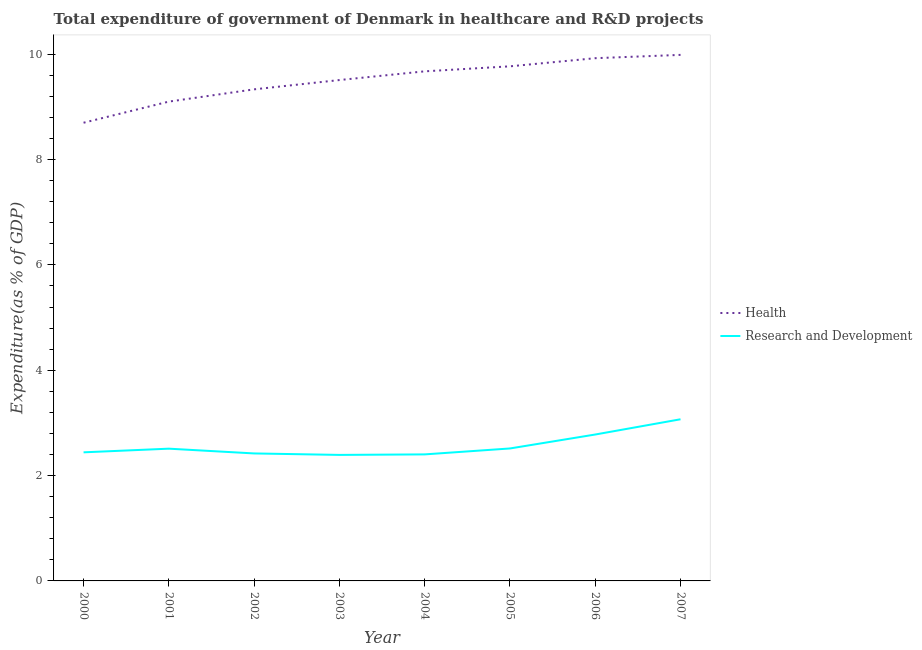Does the line corresponding to expenditure in r&d intersect with the line corresponding to expenditure in healthcare?
Keep it short and to the point. No. What is the expenditure in healthcare in 2003?
Give a very brief answer. 9.51. Across all years, what is the maximum expenditure in r&d?
Give a very brief answer. 3.07. Across all years, what is the minimum expenditure in healthcare?
Offer a very short reply. 8.7. In which year was the expenditure in healthcare maximum?
Make the answer very short. 2007. In which year was the expenditure in healthcare minimum?
Give a very brief answer. 2000. What is the total expenditure in r&d in the graph?
Your response must be concise. 20.53. What is the difference between the expenditure in healthcare in 2003 and that in 2006?
Give a very brief answer. -0.41. What is the difference between the expenditure in healthcare in 2007 and the expenditure in r&d in 2002?
Offer a terse response. 7.57. What is the average expenditure in r&d per year?
Keep it short and to the point. 2.57. In the year 2000, what is the difference between the expenditure in r&d and expenditure in healthcare?
Your answer should be very brief. -6.26. In how many years, is the expenditure in healthcare greater than 2.8 %?
Provide a short and direct response. 8. What is the ratio of the expenditure in healthcare in 2004 to that in 2007?
Provide a succinct answer. 0.97. Is the expenditure in healthcare in 2003 less than that in 2007?
Your answer should be very brief. Yes. What is the difference between the highest and the second highest expenditure in healthcare?
Make the answer very short. 0.06. What is the difference between the highest and the lowest expenditure in healthcare?
Your response must be concise. 1.29. Is the sum of the expenditure in r&d in 2005 and 2006 greater than the maximum expenditure in healthcare across all years?
Keep it short and to the point. No. Does the expenditure in r&d monotonically increase over the years?
Offer a very short reply. No. Is the expenditure in healthcare strictly greater than the expenditure in r&d over the years?
Your response must be concise. Yes. How many lines are there?
Offer a very short reply. 2. How many years are there in the graph?
Offer a very short reply. 8. Are the values on the major ticks of Y-axis written in scientific E-notation?
Ensure brevity in your answer.  No. How many legend labels are there?
Keep it short and to the point. 2. How are the legend labels stacked?
Your response must be concise. Vertical. What is the title of the graph?
Your response must be concise. Total expenditure of government of Denmark in healthcare and R&D projects. What is the label or title of the Y-axis?
Keep it short and to the point. Expenditure(as % of GDP). What is the Expenditure(as % of GDP) of Health in 2000?
Keep it short and to the point. 8.7. What is the Expenditure(as % of GDP) in Research and Development in 2000?
Provide a short and direct response. 2.44. What is the Expenditure(as % of GDP) of Health in 2001?
Ensure brevity in your answer.  9.1. What is the Expenditure(as % of GDP) of Research and Development in 2001?
Give a very brief answer. 2.51. What is the Expenditure(as % of GDP) in Health in 2002?
Give a very brief answer. 9.33. What is the Expenditure(as % of GDP) in Research and Development in 2002?
Keep it short and to the point. 2.42. What is the Expenditure(as % of GDP) in Health in 2003?
Offer a terse response. 9.51. What is the Expenditure(as % of GDP) of Research and Development in 2003?
Your answer should be compact. 2.39. What is the Expenditure(as % of GDP) in Health in 2004?
Make the answer very short. 9.67. What is the Expenditure(as % of GDP) in Research and Development in 2004?
Your response must be concise. 2.4. What is the Expenditure(as % of GDP) of Health in 2005?
Your answer should be very brief. 9.77. What is the Expenditure(as % of GDP) in Research and Development in 2005?
Your answer should be very brief. 2.51. What is the Expenditure(as % of GDP) of Health in 2006?
Offer a very short reply. 9.92. What is the Expenditure(as % of GDP) of Research and Development in 2006?
Provide a succinct answer. 2.78. What is the Expenditure(as % of GDP) of Health in 2007?
Ensure brevity in your answer.  9.99. What is the Expenditure(as % of GDP) of Research and Development in 2007?
Ensure brevity in your answer.  3.07. Across all years, what is the maximum Expenditure(as % of GDP) of Health?
Your answer should be compact. 9.99. Across all years, what is the maximum Expenditure(as % of GDP) of Research and Development?
Provide a succinct answer. 3.07. Across all years, what is the minimum Expenditure(as % of GDP) of Health?
Provide a succinct answer. 8.7. Across all years, what is the minimum Expenditure(as % of GDP) in Research and Development?
Your response must be concise. 2.39. What is the total Expenditure(as % of GDP) of Health in the graph?
Offer a terse response. 76. What is the total Expenditure(as % of GDP) of Research and Development in the graph?
Offer a terse response. 20.53. What is the difference between the Expenditure(as % of GDP) in Health in 2000 and that in 2001?
Offer a terse response. -0.4. What is the difference between the Expenditure(as % of GDP) in Research and Development in 2000 and that in 2001?
Provide a short and direct response. -0.07. What is the difference between the Expenditure(as % of GDP) in Health in 2000 and that in 2002?
Ensure brevity in your answer.  -0.63. What is the difference between the Expenditure(as % of GDP) of Research and Development in 2000 and that in 2002?
Make the answer very short. 0.02. What is the difference between the Expenditure(as % of GDP) in Health in 2000 and that in 2003?
Keep it short and to the point. -0.81. What is the difference between the Expenditure(as % of GDP) of Research and Development in 2000 and that in 2003?
Make the answer very short. 0.05. What is the difference between the Expenditure(as % of GDP) in Health in 2000 and that in 2004?
Give a very brief answer. -0.98. What is the difference between the Expenditure(as % of GDP) of Research and Development in 2000 and that in 2004?
Provide a succinct answer. 0.04. What is the difference between the Expenditure(as % of GDP) in Health in 2000 and that in 2005?
Your answer should be very brief. -1.07. What is the difference between the Expenditure(as % of GDP) in Research and Development in 2000 and that in 2005?
Your answer should be very brief. -0.07. What is the difference between the Expenditure(as % of GDP) of Health in 2000 and that in 2006?
Offer a very short reply. -1.23. What is the difference between the Expenditure(as % of GDP) of Research and Development in 2000 and that in 2006?
Ensure brevity in your answer.  -0.34. What is the difference between the Expenditure(as % of GDP) of Health in 2000 and that in 2007?
Provide a short and direct response. -1.29. What is the difference between the Expenditure(as % of GDP) of Research and Development in 2000 and that in 2007?
Offer a very short reply. -0.63. What is the difference between the Expenditure(as % of GDP) in Health in 2001 and that in 2002?
Provide a short and direct response. -0.23. What is the difference between the Expenditure(as % of GDP) of Research and Development in 2001 and that in 2002?
Offer a terse response. 0.09. What is the difference between the Expenditure(as % of GDP) in Health in 2001 and that in 2003?
Offer a very short reply. -0.41. What is the difference between the Expenditure(as % of GDP) in Research and Development in 2001 and that in 2003?
Offer a very short reply. 0.12. What is the difference between the Expenditure(as % of GDP) of Health in 2001 and that in 2004?
Offer a terse response. -0.57. What is the difference between the Expenditure(as % of GDP) of Research and Development in 2001 and that in 2004?
Provide a short and direct response. 0.11. What is the difference between the Expenditure(as % of GDP) of Health in 2001 and that in 2005?
Keep it short and to the point. -0.67. What is the difference between the Expenditure(as % of GDP) of Research and Development in 2001 and that in 2005?
Provide a succinct answer. -0. What is the difference between the Expenditure(as % of GDP) of Health in 2001 and that in 2006?
Give a very brief answer. -0.82. What is the difference between the Expenditure(as % of GDP) of Research and Development in 2001 and that in 2006?
Your response must be concise. -0.27. What is the difference between the Expenditure(as % of GDP) of Health in 2001 and that in 2007?
Provide a succinct answer. -0.89. What is the difference between the Expenditure(as % of GDP) in Research and Development in 2001 and that in 2007?
Offer a terse response. -0.56. What is the difference between the Expenditure(as % of GDP) in Health in 2002 and that in 2003?
Your answer should be very brief. -0.18. What is the difference between the Expenditure(as % of GDP) in Research and Development in 2002 and that in 2003?
Your response must be concise. 0.03. What is the difference between the Expenditure(as % of GDP) of Health in 2002 and that in 2004?
Provide a short and direct response. -0.34. What is the difference between the Expenditure(as % of GDP) in Research and Development in 2002 and that in 2004?
Your answer should be compact. 0.02. What is the difference between the Expenditure(as % of GDP) of Health in 2002 and that in 2005?
Ensure brevity in your answer.  -0.44. What is the difference between the Expenditure(as % of GDP) in Research and Development in 2002 and that in 2005?
Your answer should be compact. -0.09. What is the difference between the Expenditure(as % of GDP) in Health in 2002 and that in 2006?
Give a very brief answer. -0.59. What is the difference between the Expenditure(as % of GDP) in Research and Development in 2002 and that in 2006?
Offer a very short reply. -0.36. What is the difference between the Expenditure(as % of GDP) in Health in 2002 and that in 2007?
Your answer should be compact. -0.65. What is the difference between the Expenditure(as % of GDP) of Research and Development in 2002 and that in 2007?
Give a very brief answer. -0.65. What is the difference between the Expenditure(as % of GDP) of Health in 2003 and that in 2004?
Keep it short and to the point. -0.17. What is the difference between the Expenditure(as % of GDP) in Research and Development in 2003 and that in 2004?
Provide a succinct answer. -0.01. What is the difference between the Expenditure(as % of GDP) of Health in 2003 and that in 2005?
Give a very brief answer. -0.26. What is the difference between the Expenditure(as % of GDP) of Research and Development in 2003 and that in 2005?
Your answer should be very brief. -0.12. What is the difference between the Expenditure(as % of GDP) of Health in 2003 and that in 2006?
Provide a succinct answer. -0.41. What is the difference between the Expenditure(as % of GDP) in Research and Development in 2003 and that in 2006?
Offer a terse response. -0.39. What is the difference between the Expenditure(as % of GDP) in Health in 2003 and that in 2007?
Offer a terse response. -0.48. What is the difference between the Expenditure(as % of GDP) in Research and Development in 2003 and that in 2007?
Make the answer very short. -0.68. What is the difference between the Expenditure(as % of GDP) of Health in 2004 and that in 2005?
Offer a very short reply. -0.1. What is the difference between the Expenditure(as % of GDP) of Research and Development in 2004 and that in 2005?
Your answer should be compact. -0.11. What is the difference between the Expenditure(as % of GDP) in Health in 2004 and that in 2006?
Offer a very short reply. -0.25. What is the difference between the Expenditure(as % of GDP) of Research and Development in 2004 and that in 2006?
Your answer should be very brief. -0.38. What is the difference between the Expenditure(as % of GDP) of Health in 2004 and that in 2007?
Offer a very short reply. -0.31. What is the difference between the Expenditure(as % of GDP) of Research and Development in 2004 and that in 2007?
Keep it short and to the point. -0.67. What is the difference between the Expenditure(as % of GDP) of Health in 2005 and that in 2006?
Your answer should be compact. -0.15. What is the difference between the Expenditure(as % of GDP) of Research and Development in 2005 and that in 2006?
Keep it short and to the point. -0.26. What is the difference between the Expenditure(as % of GDP) of Health in 2005 and that in 2007?
Keep it short and to the point. -0.22. What is the difference between the Expenditure(as % of GDP) of Research and Development in 2005 and that in 2007?
Give a very brief answer. -0.55. What is the difference between the Expenditure(as % of GDP) of Health in 2006 and that in 2007?
Your answer should be very brief. -0.06. What is the difference between the Expenditure(as % of GDP) of Research and Development in 2006 and that in 2007?
Provide a succinct answer. -0.29. What is the difference between the Expenditure(as % of GDP) of Health in 2000 and the Expenditure(as % of GDP) of Research and Development in 2001?
Your answer should be very brief. 6.19. What is the difference between the Expenditure(as % of GDP) in Health in 2000 and the Expenditure(as % of GDP) in Research and Development in 2002?
Your answer should be very brief. 6.28. What is the difference between the Expenditure(as % of GDP) in Health in 2000 and the Expenditure(as % of GDP) in Research and Development in 2003?
Keep it short and to the point. 6.31. What is the difference between the Expenditure(as % of GDP) of Health in 2000 and the Expenditure(as % of GDP) of Research and Development in 2004?
Ensure brevity in your answer.  6.3. What is the difference between the Expenditure(as % of GDP) in Health in 2000 and the Expenditure(as % of GDP) in Research and Development in 2005?
Your answer should be compact. 6.18. What is the difference between the Expenditure(as % of GDP) in Health in 2000 and the Expenditure(as % of GDP) in Research and Development in 2006?
Your answer should be compact. 5.92. What is the difference between the Expenditure(as % of GDP) of Health in 2000 and the Expenditure(as % of GDP) of Research and Development in 2007?
Offer a very short reply. 5.63. What is the difference between the Expenditure(as % of GDP) in Health in 2001 and the Expenditure(as % of GDP) in Research and Development in 2002?
Provide a short and direct response. 6.68. What is the difference between the Expenditure(as % of GDP) of Health in 2001 and the Expenditure(as % of GDP) of Research and Development in 2003?
Your response must be concise. 6.71. What is the difference between the Expenditure(as % of GDP) in Health in 2001 and the Expenditure(as % of GDP) in Research and Development in 2004?
Your answer should be compact. 6.7. What is the difference between the Expenditure(as % of GDP) in Health in 2001 and the Expenditure(as % of GDP) in Research and Development in 2005?
Keep it short and to the point. 6.59. What is the difference between the Expenditure(as % of GDP) in Health in 2001 and the Expenditure(as % of GDP) in Research and Development in 2006?
Keep it short and to the point. 6.32. What is the difference between the Expenditure(as % of GDP) of Health in 2001 and the Expenditure(as % of GDP) of Research and Development in 2007?
Give a very brief answer. 6.03. What is the difference between the Expenditure(as % of GDP) of Health in 2002 and the Expenditure(as % of GDP) of Research and Development in 2003?
Your answer should be very brief. 6.94. What is the difference between the Expenditure(as % of GDP) in Health in 2002 and the Expenditure(as % of GDP) in Research and Development in 2004?
Keep it short and to the point. 6.93. What is the difference between the Expenditure(as % of GDP) of Health in 2002 and the Expenditure(as % of GDP) of Research and Development in 2005?
Keep it short and to the point. 6.82. What is the difference between the Expenditure(as % of GDP) of Health in 2002 and the Expenditure(as % of GDP) of Research and Development in 2006?
Make the answer very short. 6.55. What is the difference between the Expenditure(as % of GDP) in Health in 2002 and the Expenditure(as % of GDP) in Research and Development in 2007?
Provide a short and direct response. 6.26. What is the difference between the Expenditure(as % of GDP) of Health in 2003 and the Expenditure(as % of GDP) of Research and Development in 2004?
Keep it short and to the point. 7.11. What is the difference between the Expenditure(as % of GDP) of Health in 2003 and the Expenditure(as % of GDP) of Research and Development in 2005?
Offer a very short reply. 6.99. What is the difference between the Expenditure(as % of GDP) of Health in 2003 and the Expenditure(as % of GDP) of Research and Development in 2006?
Your answer should be compact. 6.73. What is the difference between the Expenditure(as % of GDP) in Health in 2003 and the Expenditure(as % of GDP) in Research and Development in 2007?
Offer a very short reply. 6.44. What is the difference between the Expenditure(as % of GDP) of Health in 2004 and the Expenditure(as % of GDP) of Research and Development in 2005?
Offer a terse response. 7.16. What is the difference between the Expenditure(as % of GDP) in Health in 2004 and the Expenditure(as % of GDP) in Research and Development in 2006?
Provide a short and direct response. 6.9. What is the difference between the Expenditure(as % of GDP) of Health in 2004 and the Expenditure(as % of GDP) of Research and Development in 2007?
Give a very brief answer. 6.61. What is the difference between the Expenditure(as % of GDP) of Health in 2005 and the Expenditure(as % of GDP) of Research and Development in 2006?
Provide a short and direct response. 6.99. What is the difference between the Expenditure(as % of GDP) in Health in 2005 and the Expenditure(as % of GDP) in Research and Development in 2007?
Your response must be concise. 6.7. What is the difference between the Expenditure(as % of GDP) in Health in 2006 and the Expenditure(as % of GDP) in Research and Development in 2007?
Provide a short and direct response. 6.86. What is the average Expenditure(as % of GDP) in Health per year?
Offer a terse response. 9.5. What is the average Expenditure(as % of GDP) in Research and Development per year?
Keep it short and to the point. 2.57. In the year 2000, what is the difference between the Expenditure(as % of GDP) in Health and Expenditure(as % of GDP) in Research and Development?
Make the answer very short. 6.26. In the year 2001, what is the difference between the Expenditure(as % of GDP) in Health and Expenditure(as % of GDP) in Research and Development?
Offer a very short reply. 6.59. In the year 2002, what is the difference between the Expenditure(as % of GDP) in Health and Expenditure(as % of GDP) in Research and Development?
Your answer should be very brief. 6.91. In the year 2003, what is the difference between the Expenditure(as % of GDP) in Health and Expenditure(as % of GDP) in Research and Development?
Keep it short and to the point. 7.12. In the year 2004, what is the difference between the Expenditure(as % of GDP) in Health and Expenditure(as % of GDP) in Research and Development?
Provide a succinct answer. 7.27. In the year 2005, what is the difference between the Expenditure(as % of GDP) of Health and Expenditure(as % of GDP) of Research and Development?
Give a very brief answer. 7.26. In the year 2006, what is the difference between the Expenditure(as % of GDP) of Health and Expenditure(as % of GDP) of Research and Development?
Provide a succinct answer. 7.14. In the year 2007, what is the difference between the Expenditure(as % of GDP) of Health and Expenditure(as % of GDP) of Research and Development?
Keep it short and to the point. 6.92. What is the ratio of the Expenditure(as % of GDP) in Health in 2000 to that in 2001?
Provide a short and direct response. 0.96. What is the ratio of the Expenditure(as % of GDP) of Research and Development in 2000 to that in 2001?
Give a very brief answer. 0.97. What is the ratio of the Expenditure(as % of GDP) of Health in 2000 to that in 2002?
Keep it short and to the point. 0.93. What is the ratio of the Expenditure(as % of GDP) in Research and Development in 2000 to that in 2002?
Ensure brevity in your answer.  1.01. What is the ratio of the Expenditure(as % of GDP) of Health in 2000 to that in 2003?
Offer a terse response. 0.91. What is the ratio of the Expenditure(as % of GDP) of Research and Development in 2000 to that in 2003?
Your response must be concise. 1.02. What is the ratio of the Expenditure(as % of GDP) in Health in 2000 to that in 2004?
Your answer should be compact. 0.9. What is the ratio of the Expenditure(as % of GDP) of Research and Development in 2000 to that in 2004?
Your answer should be very brief. 1.02. What is the ratio of the Expenditure(as % of GDP) in Health in 2000 to that in 2005?
Make the answer very short. 0.89. What is the ratio of the Expenditure(as % of GDP) of Research and Development in 2000 to that in 2005?
Your response must be concise. 0.97. What is the ratio of the Expenditure(as % of GDP) in Health in 2000 to that in 2006?
Your answer should be very brief. 0.88. What is the ratio of the Expenditure(as % of GDP) in Research and Development in 2000 to that in 2006?
Give a very brief answer. 0.88. What is the ratio of the Expenditure(as % of GDP) of Health in 2000 to that in 2007?
Offer a very short reply. 0.87. What is the ratio of the Expenditure(as % of GDP) in Research and Development in 2000 to that in 2007?
Offer a terse response. 0.8. What is the ratio of the Expenditure(as % of GDP) of Health in 2001 to that in 2002?
Your answer should be very brief. 0.98. What is the ratio of the Expenditure(as % of GDP) of Research and Development in 2001 to that in 2002?
Your response must be concise. 1.04. What is the ratio of the Expenditure(as % of GDP) in Health in 2001 to that in 2003?
Make the answer very short. 0.96. What is the ratio of the Expenditure(as % of GDP) in Research and Development in 2001 to that in 2003?
Keep it short and to the point. 1.05. What is the ratio of the Expenditure(as % of GDP) in Health in 2001 to that in 2004?
Keep it short and to the point. 0.94. What is the ratio of the Expenditure(as % of GDP) of Research and Development in 2001 to that in 2004?
Keep it short and to the point. 1.05. What is the ratio of the Expenditure(as % of GDP) in Health in 2001 to that in 2005?
Give a very brief answer. 0.93. What is the ratio of the Expenditure(as % of GDP) in Research and Development in 2001 to that in 2005?
Your response must be concise. 1. What is the ratio of the Expenditure(as % of GDP) of Health in 2001 to that in 2006?
Ensure brevity in your answer.  0.92. What is the ratio of the Expenditure(as % of GDP) in Research and Development in 2001 to that in 2006?
Provide a succinct answer. 0.9. What is the ratio of the Expenditure(as % of GDP) of Health in 2001 to that in 2007?
Offer a very short reply. 0.91. What is the ratio of the Expenditure(as % of GDP) of Research and Development in 2001 to that in 2007?
Provide a short and direct response. 0.82. What is the ratio of the Expenditure(as % of GDP) of Health in 2002 to that in 2003?
Offer a terse response. 0.98. What is the ratio of the Expenditure(as % of GDP) of Research and Development in 2002 to that in 2003?
Keep it short and to the point. 1.01. What is the ratio of the Expenditure(as % of GDP) in Health in 2002 to that in 2004?
Offer a terse response. 0.96. What is the ratio of the Expenditure(as % of GDP) in Research and Development in 2002 to that in 2004?
Your response must be concise. 1.01. What is the ratio of the Expenditure(as % of GDP) in Health in 2002 to that in 2005?
Your answer should be compact. 0.96. What is the ratio of the Expenditure(as % of GDP) in Research and Development in 2002 to that in 2005?
Provide a short and direct response. 0.96. What is the ratio of the Expenditure(as % of GDP) of Health in 2002 to that in 2006?
Keep it short and to the point. 0.94. What is the ratio of the Expenditure(as % of GDP) in Research and Development in 2002 to that in 2006?
Keep it short and to the point. 0.87. What is the ratio of the Expenditure(as % of GDP) of Health in 2002 to that in 2007?
Make the answer very short. 0.93. What is the ratio of the Expenditure(as % of GDP) of Research and Development in 2002 to that in 2007?
Offer a terse response. 0.79. What is the ratio of the Expenditure(as % of GDP) in Health in 2003 to that in 2004?
Provide a succinct answer. 0.98. What is the ratio of the Expenditure(as % of GDP) in Health in 2003 to that in 2005?
Offer a terse response. 0.97. What is the ratio of the Expenditure(as % of GDP) in Research and Development in 2003 to that in 2005?
Keep it short and to the point. 0.95. What is the ratio of the Expenditure(as % of GDP) in Health in 2003 to that in 2006?
Ensure brevity in your answer.  0.96. What is the ratio of the Expenditure(as % of GDP) in Research and Development in 2003 to that in 2006?
Your response must be concise. 0.86. What is the ratio of the Expenditure(as % of GDP) in Health in 2003 to that in 2007?
Your answer should be very brief. 0.95. What is the ratio of the Expenditure(as % of GDP) in Research and Development in 2003 to that in 2007?
Provide a short and direct response. 0.78. What is the ratio of the Expenditure(as % of GDP) of Health in 2004 to that in 2005?
Your answer should be very brief. 0.99. What is the ratio of the Expenditure(as % of GDP) in Research and Development in 2004 to that in 2005?
Provide a succinct answer. 0.96. What is the ratio of the Expenditure(as % of GDP) of Health in 2004 to that in 2006?
Your response must be concise. 0.97. What is the ratio of the Expenditure(as % of GDP) in Research and Development in 2004 to that in 2006?
Your response must be concise. 0.86. What is the ratio of the Expenditure(as % of GDP) of Health in 2004 to that in 2007?
Provide a short and direct response. 0.97. What is the ratio of the Expenditure(as % of GDP) in Research and Development in 2004 to that in 2007?
Ensure brevity in your answer.  0.78. What is the ratio of the Expenditure(as % of GDP) of Health in 2005 to that in 2006?
Provide a succinct answer. 0.98. What is the ratio of the Expenditure(as % of GDP) in Research and Development in 2005 to that in 2006?
Your response must be concise. 0.9. What is the ratio of the Expenditure(as % of GDP) of Health in 2005 to that in 2007?
Give a very brief answer. 0.98. What is the ratio of the Expenditure(as % of GDP) of Research and Development in 2005 to that in 2007?
Give a very brief answer. 0.82. What is the ratio of the Expenditure(as % of GDP) in Health in 2006 to that in 2007?
Your response must be concise. 0.99. What is the ratio of the Expenditure(as % of GDP) of Research and Development in 2006 to that in 2007?
Keep it short and to the point. 0.91. What is the difference between the highest and the second highest Expenditure(as % of GDP) in Health?
Your response must be concise. 0.06. What is the difference between the highest and the second highest Expenditure(as % of GDP) of Research and Development?
Provide a short and direct response. 0.29. What is the difference between the highest and the lowest Expenditure(as % of GDP) of Health?
Your answer should be compact. 1.29. What is the difference between the highest and the lowest Expenditure(as % of GDP) in Research and Development?
Provide a short and direct response. 0.68. 